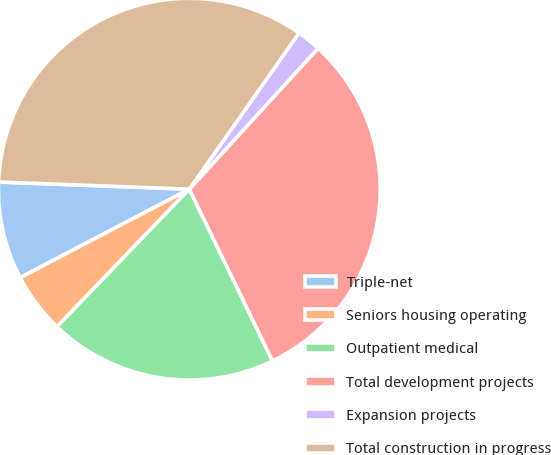<chart> <loc_0><loc_0><loc_500><loc_500><pie_chart><fcel>Triple-net<fcel>Seniors housing operating<fcel>Outpatient medical<fcel>Total development projects<fcel>Expansion projects<fcel>Total construction in progress<nl><fcel>8.27%<fcel>5.14%<fcel>19.37%<fcel>31.04%<fcel>2.04%<fcel>34.14%<nl></chart> 